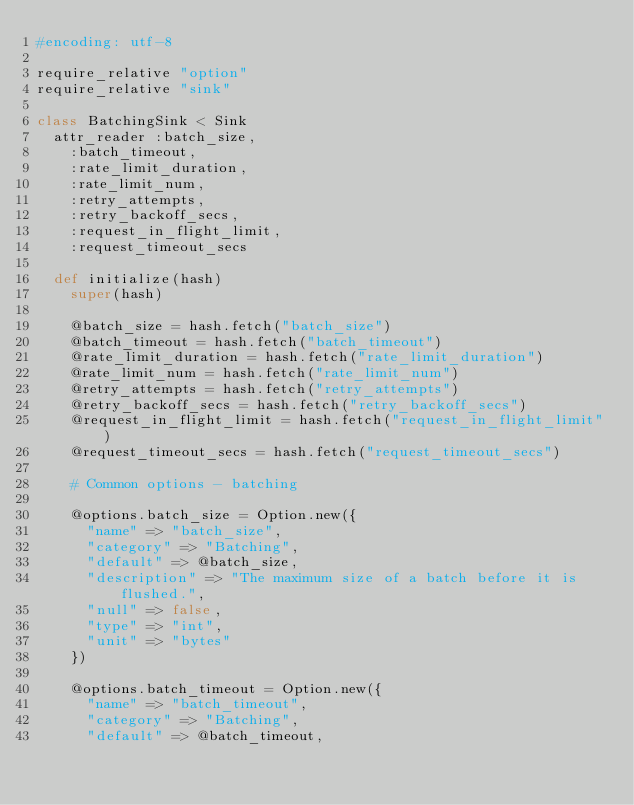<code> <loc_0><loc_0><loc_500><loc_500><_Ruby_>#encoding: utf-8

require_relative "option"
require_relative "sink"

class BatchingSink < Sink
  attr_reader :batch_size,
    :batch_timeout,
    :rate_limit_duration,
    :rate_limit_num,
    :retry_attempts,
    :retry_backoff_secs,
    :request_in_flight_limit,
    :request_timeout_secs

  def initialize(hash)
    super(hash)

    @batch_size = hash.fetch("batch_size")
    @batch_timeout = hash.fetch("batch_timeout")
    @rate_limit_duration = hash.fetch("rate_limit_duration")
    @rate_limit_num = hash.fetch("rate_limit_num")
    @retry_attempts = hash.fetch("retry_attempts")
    @retry_backoff_secs = hash.fetch("retry_backoff_secs")
    @request_in_flight_limit = hash.fetch("request_in_flight_limit")
    @request_timeout_secs = hash.fetch("request_timeout_secs")

    # Common options - batching

    @options.batch_size = Option.new({
      "name" => "batch_size",
      "category" => "Batching",
      "default" => @batch_size,
      "description" => "The maximum size of a batch before it is flushed.",
      "null" => false,
      "type" => "int",
      "unit" => "bytes"
    })

    @options.batch_timeout = Option.new({
      "name" => "batch_timeout",
      "category" => "Batching",
      "default" => @batch_timeout,</code> 